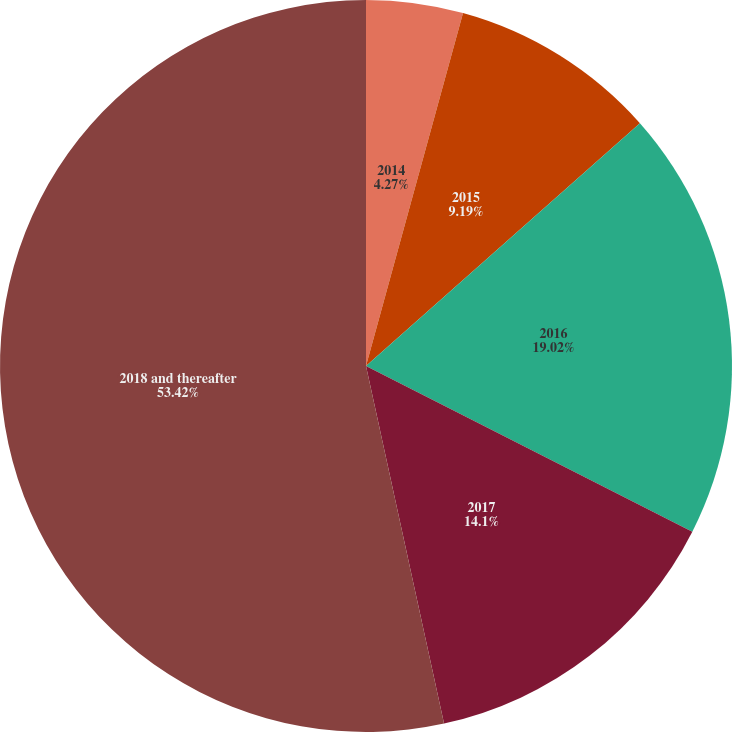Convert chart to OTSL. <chart><loc_0><loc_0><loc_500><loc_500><pie_chart><fcel>2014<fcel>2015<fcel>2016<fcel>2017<fcel>2018 and thereafter<nl><fcel>4.27%<fcel>9.19%<fcel>19.02%<fcel>14.1%<fcel>53.42%<nl></chart> 